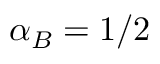<formula> <loc_0><loc_0><loc_500><loc_500>\alpha _ { B } = 1 / 2</formula> 